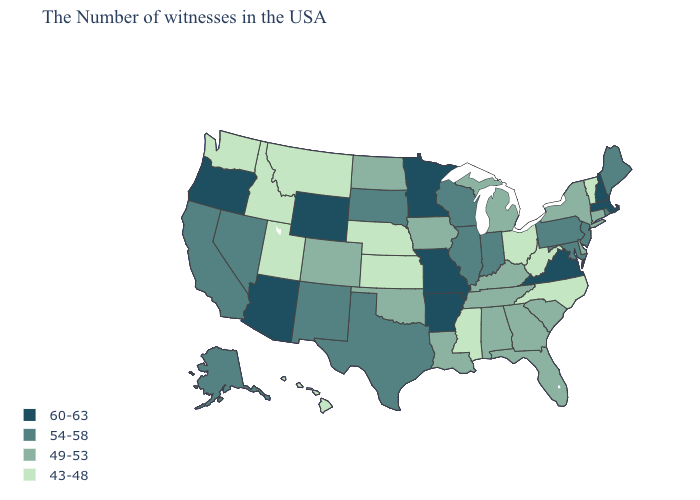What is the value of Rhode Island?
Concise answer only. 54-58. Does Delaware have a lower value than Mississippi?
Give a very brief answer. No. Name the states that have a value in the range 43-48?
Answer briefly. Vermont, North Carolina, West Virginia, Ohio, Mississippi, Kansas, Nebraska, Utah, Montana, Idaho, Washington, Hawaii. Among the states that border Oklahoma , does Kansas have the lowest value?
Give a very brief answer. Yes. Name the states that have a value in the range 60-63?
Answer briefly. Massachusetts, New Hampshire, Virginia, Missouri, Arkansas, Minnesota, Wyoming, Arizona, Oregon. Which states have the lowest value in the USA?
Write a very short answer. Vermont, North Carolina, West Virginia, Ohio, Mississippi, Kansas, Nebraska, Utah, Montana, Idaho, Washington, Hawaii. Which states have the highest value in the USA?
Write a very short answer. Massachusetts, New Hampshire, Virginia, Missouri, Arkansas, Minnesota, Wyoming, Arizona, Oregon. How many symbols are there in the legend?
Answer briefly. 4. What is the value of Ohio?
Write a very short answer. 43-48. Name the states that have a value in the range 60-63?
Short answer required. Massachusetts, New Hampshire, Virginia, Missouri, Arkansas, Minnesota, Wyoming, Arizona, Oregon. Which states hav the highest value in the MidWest?
Be succinct. Missouri, Minnesota. What is the highest value in the West ?
Be succinct. 60-63. What is the highest value in the Northeast ?
Quick response, please. 60-63. What is the value of Mississippi?
Be succinct. 43-48. Is the legend a continuous bar?
Answer briefly. No. 